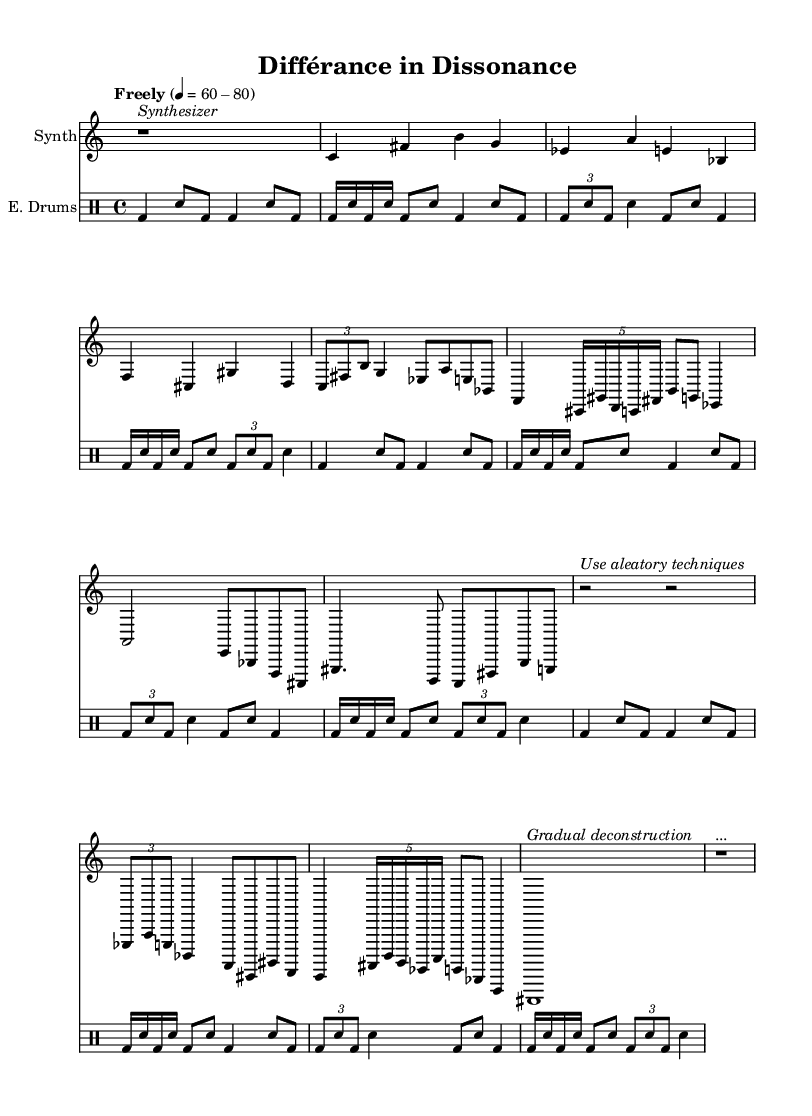What is the time signature of this music? The time signature is indicated at the beginning of the score, where "4/4" is shown. This means there are 4 beats in each measure, and the quarter note gets one beat.
Answer: 4/4 What is the tempo marking for the piece? The tempo marking reads "Freely," followed by a range indicating flexibility in speed, which can be interpreted as between 60 and 80 beats per minute.
Answer: Freely 60-80 How many sections are present in the scored music? By analyzing the structure of the piece, it can be identified that there are two distinct sections labeled as "Section A" and "Section B," along with an introduction and interlude. Counting "Section A'" as a variation gives a total of four sections.
Answer: Four What type of techniques are suggested in the interlude? The interlude suggests using "aleatory techniques," which refers to a compositional approach that incorporates elements of chance or unpredictability.
Answer: Aleatory techniques What instrument plays the main melodic line? The main melodic line is performed by the synthesizer, which is indicated by the notation and the "Synth" label at the beginning of the staff.
Answer: Synthesizer How does the rhythmic pattern change throughout the piece? The rhythmic pattern is characterized by glitchy, stuttering beats that include sudden changes in tempo and rhythmic displacement, as suggested by the drum section's varied patterns and the notation of tuplets. This denotes complexity and unpredictability throughout the piece.
Answer: Glitchy, stuttering What is the final musical instruction in the score? The coda concludes the piece with a note labeled "Gradual deconstruction," followed by a rest that indicates an ending, suggesting a reflective or unresolved close to the composition.
Answer: Gradual deconstruction 